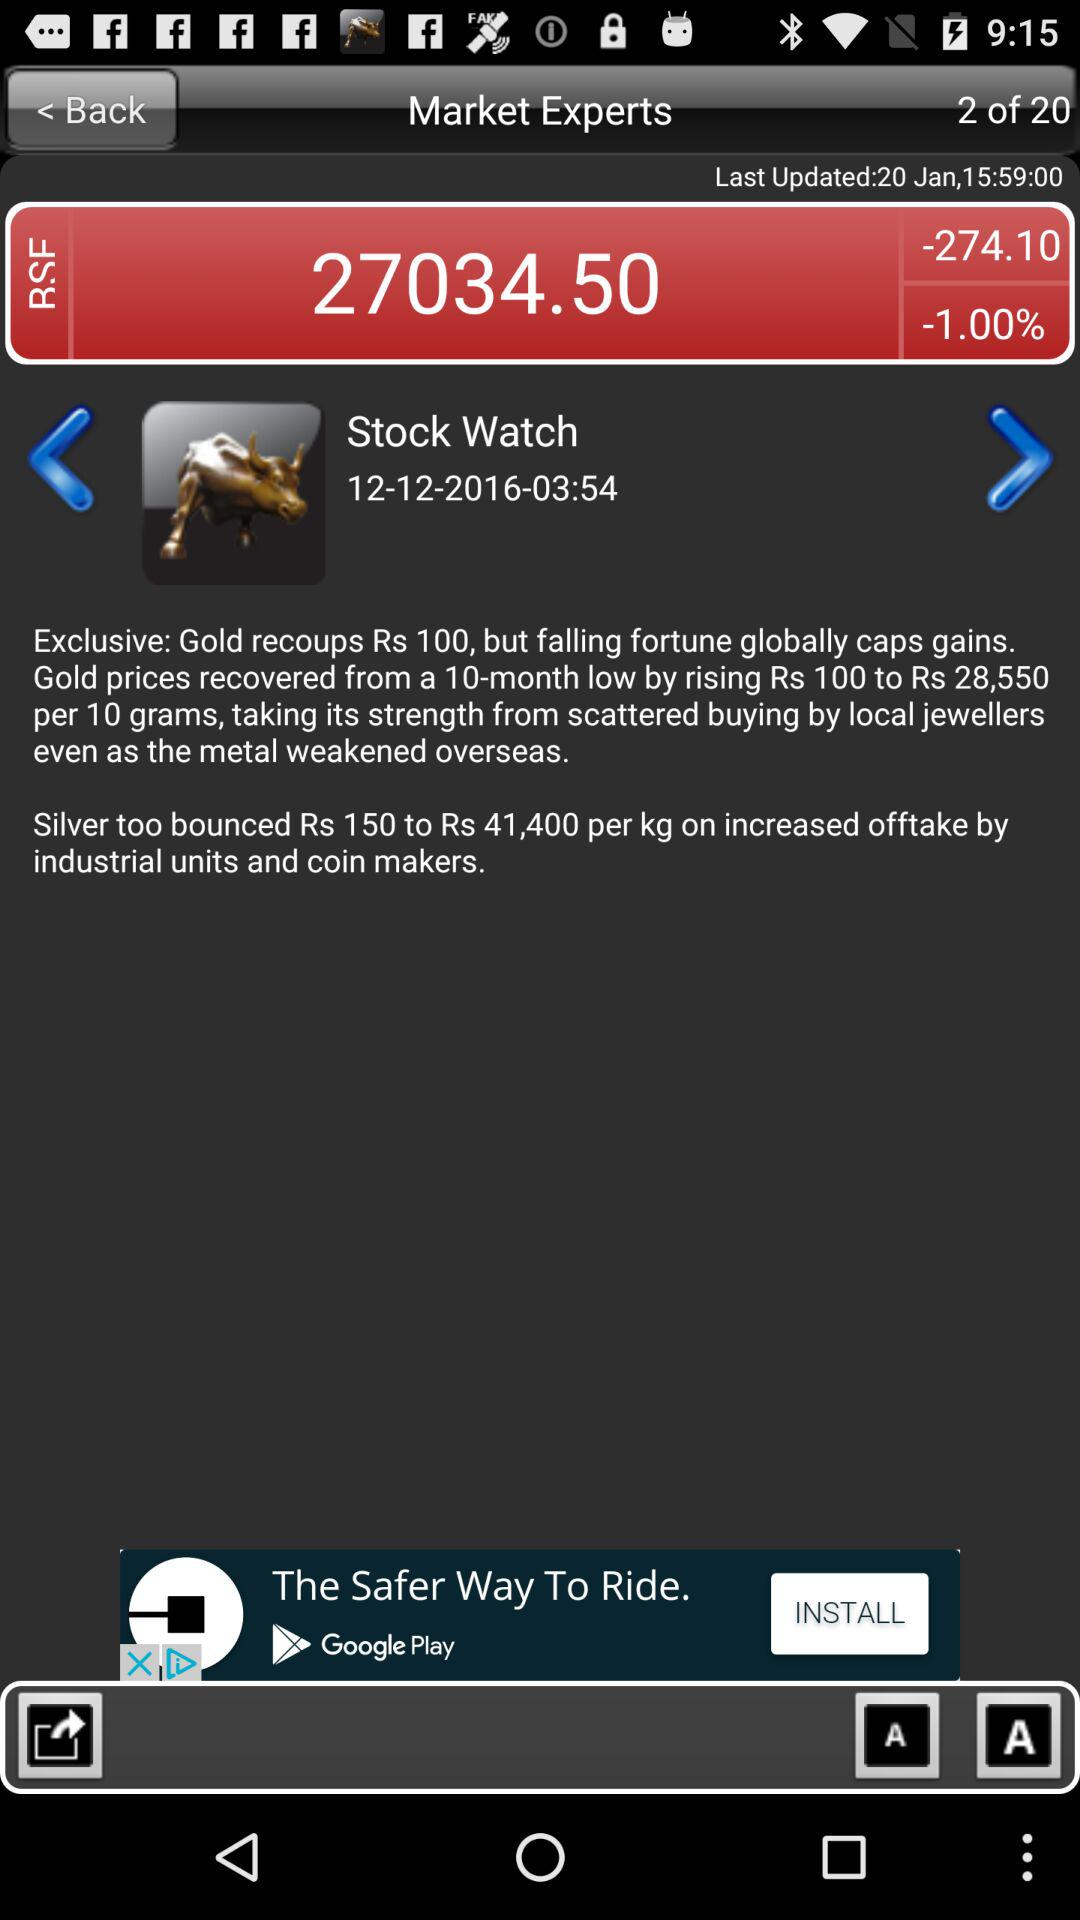How much did gold recoup in USD?
When the provided information is insufficient, respond with <no answer>. <no answer> 